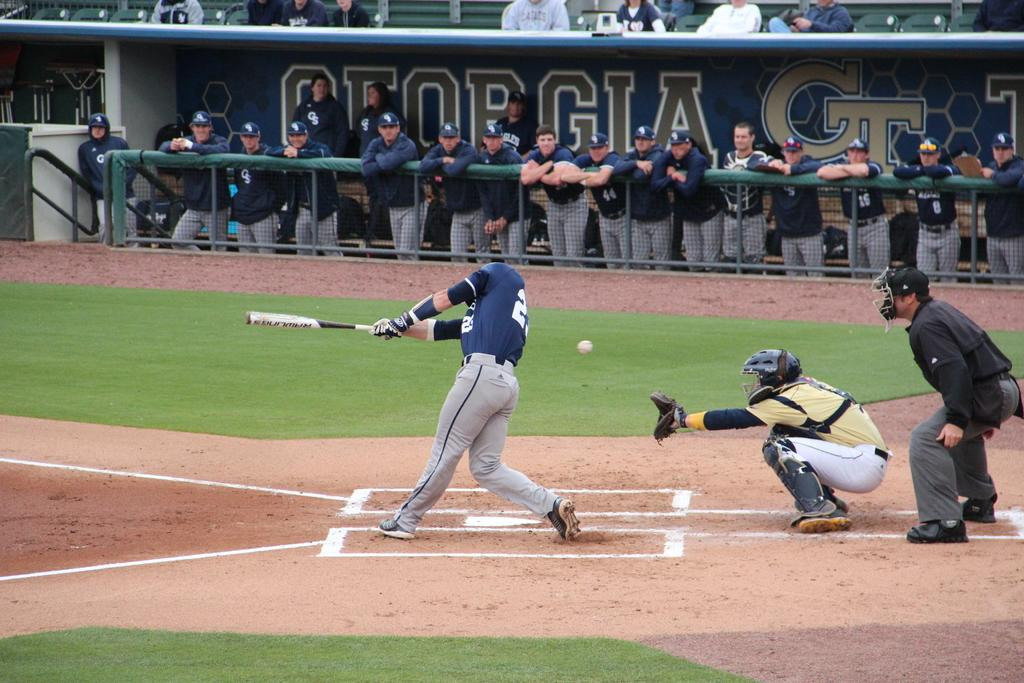<image>
Share a concise interpretation of the image provided. Baseball team dugout of the Gerogia baseball team. 